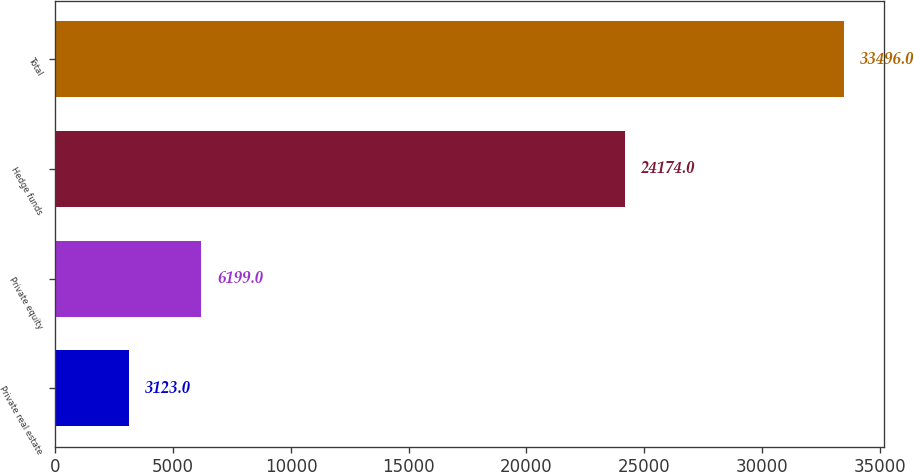Convert chart. <chart><loc_0><loc_0><loc_500><loc_500><bar_chart><fcel>Private real estate<fcel>Private equity<fcel>Hedge funds<fcel>Total<nl><fcel>3123<fcel>6199<fcel>24174<fcel>33496<nl></chart> 